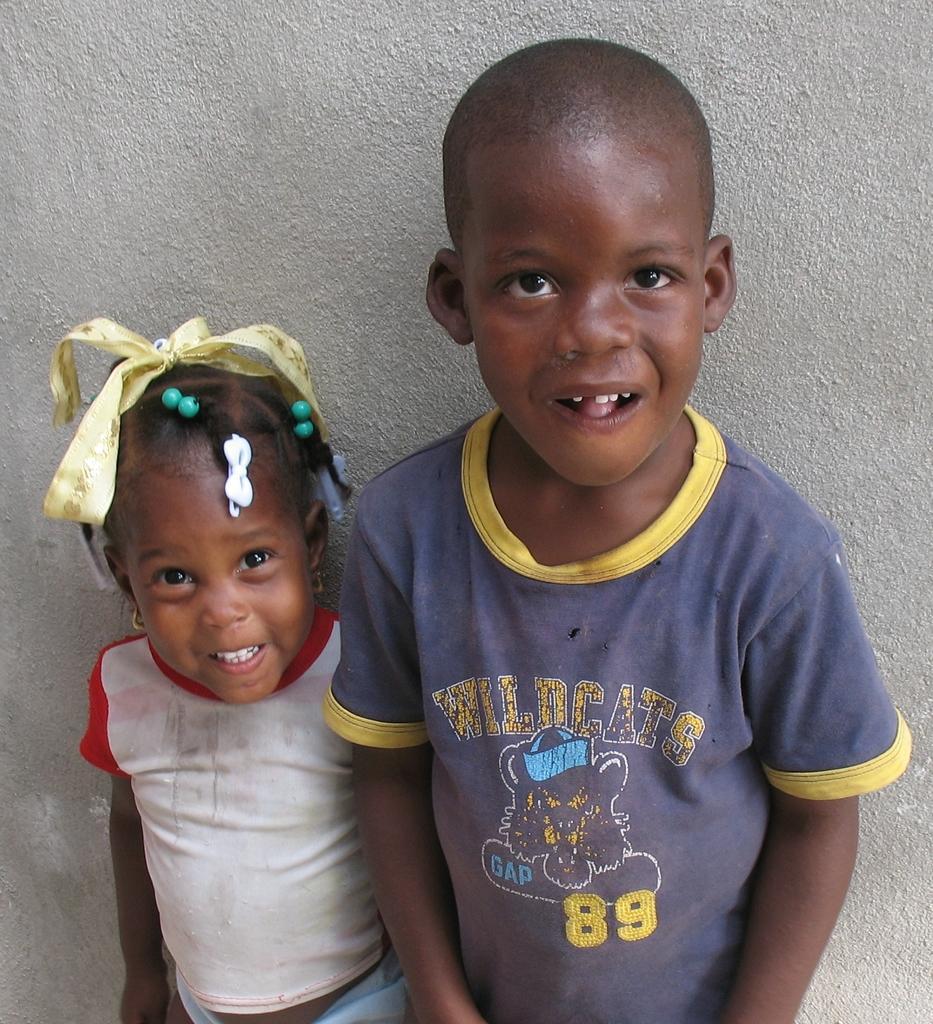Can you describe this image briefly? In the center of the image there are two kids standing. In the background of the image there is wall. 